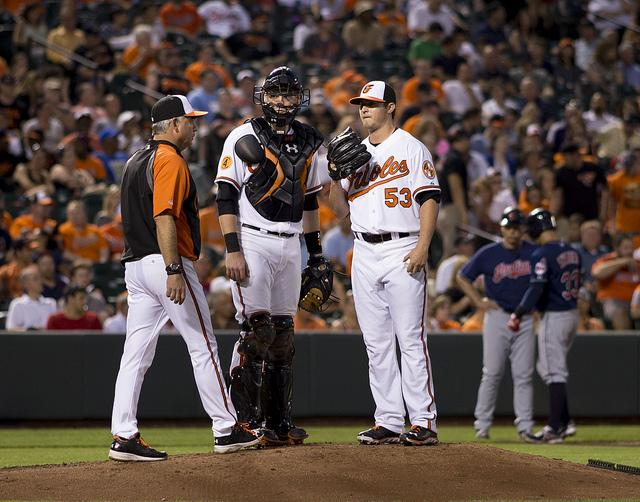Where are the three men in orange and white having their discussion?

Choices:
A) homeplate
B) pitcher's mound
C) 2nd base
D) outfield pitcher's mound 